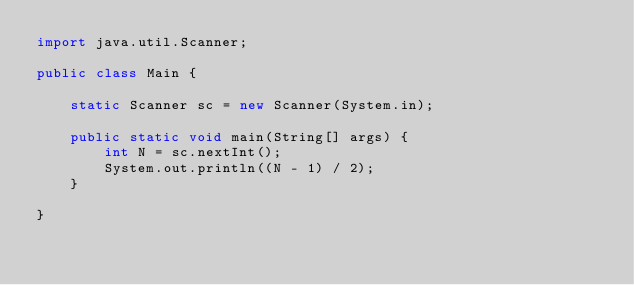<code> <loc_0><loc_0><loc_500><loc_500><_Java_>import java.util.Scanner;

public class Main {

    static Scanner sc = new Scanner(System.in);

    public static void main(String[] args) {
        int N = sc.nextInt();
        System.out.println((N - 1) / 2);
    }

}
</code> 